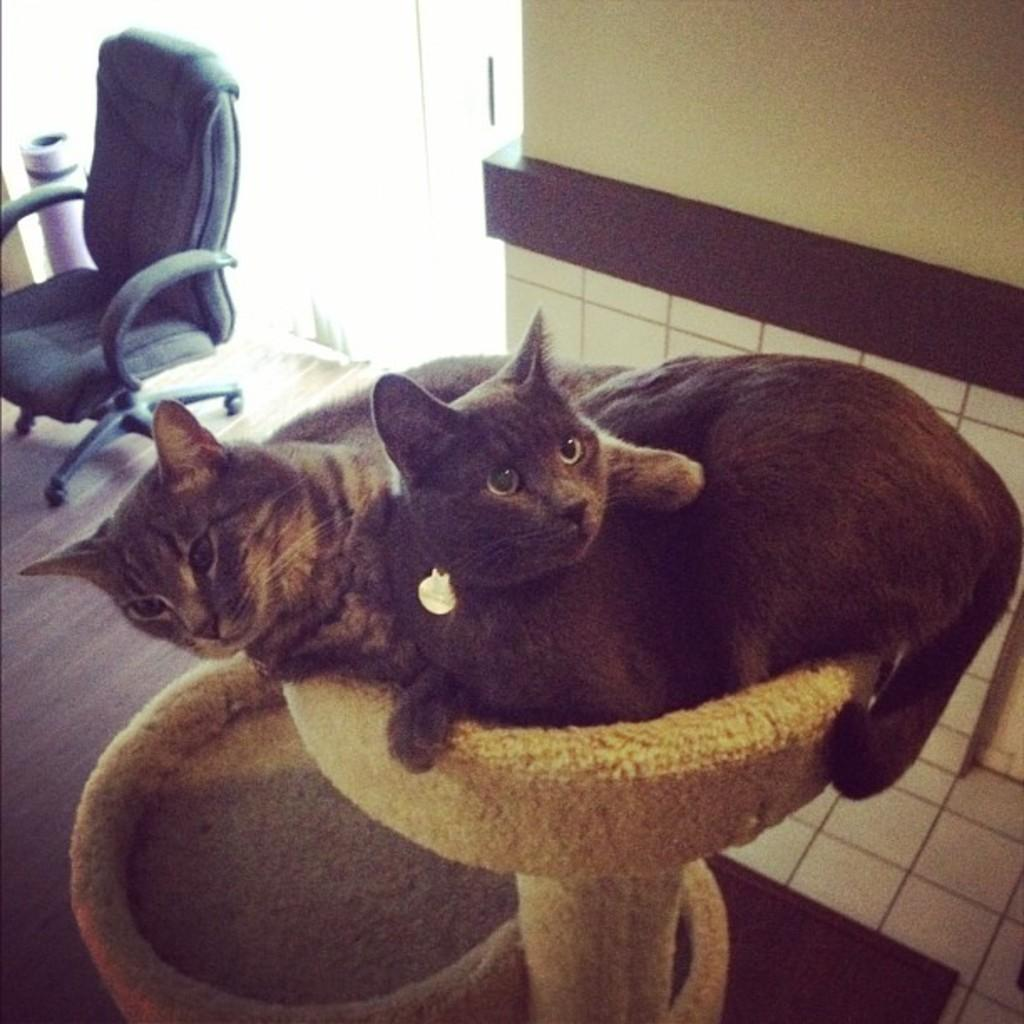How many cats are in the image? There are two cats in the image. What are the cats doing or positioned on? The cats are on an object. Can you describe any furniture in the image? There is a chair in the image. What can be seen in the background of the image? There is a wall in the background of the image. What type of vegetable is being photographed by the camera in the image? There is no vegetable or camera present in the image. What is the range of the cats in the image? The cats are not engaged in any activity that involves a range; they are simply on an object. 